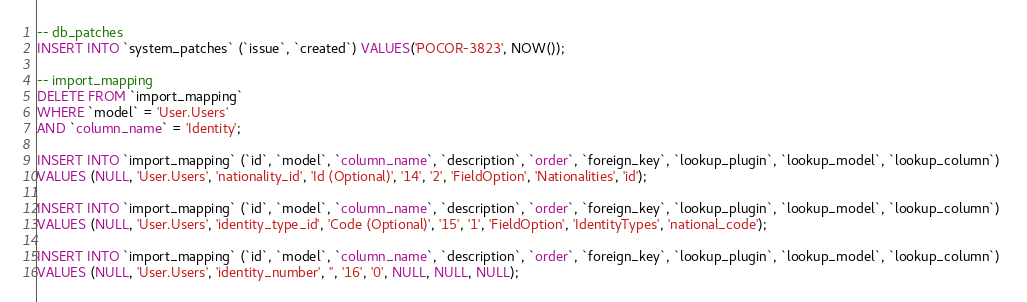Convert code to text. <code><loc_0><loc_0><loc_500><loc_500><_SQL_>-- db_patches
INSERT INTO `system_patches` (`issue`, `created`) VALUES('POCOR-3823', NOW());

-- import_mapping
DELETE FROM `import_mapping` 
WHERE `model` = 'User.Users'
AND `column_name` = 'Identity';

INSERT INTO `import_mapping` (`id`, `model`, `column_name`, `description`, `order`, `foreign_key`, `lookup_plugin`, `lookup_model`, `lookup_column`) 
VALUES (NULL, 'User.Users', 'nationality_id', 'Id (Optional)', '14', '2', 'FieldOption', 'Nationalities', 'id');

INSERT INTO `import_mapping` (`id`, `model`, `column_name`, `description`, `order`, `foreign_key`, `lookup_plugin`, `lookup_model`, `lookup_column`) 
VALUES (NULL, 'User.Users', 'identity_type_id', 'Code (Optional)', '15', '1', 'FieldOption', 'IdentityTypes', 'national_code');

INSERT INTO `import_mapping` (`id`, `model`, `column_name`, `description`, `order`, `foreign_key`, `lookup_plugin`, `lookup_model`, `lookup_column`) 
VALUES (NULL, 'User.Users', 'identity_number', '', '16', '0', NULL, NULL, NULL);</code> 